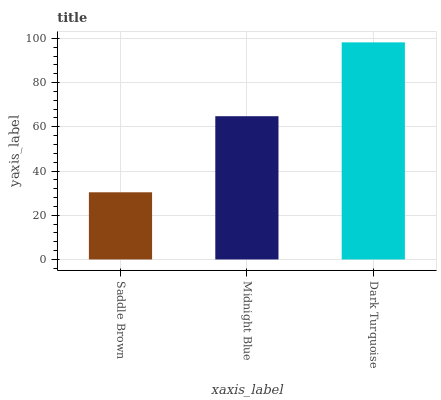Is Saddle Brown the minimum?
Answer yes or no. Yes. Is Dark Turquoise the maximum?
Answer yes or no. Yes. Is Midnight Blue the minimum?
Answer yes or no. No. Is Midnight Blue the maximum?
Answer yes or no. No. Is Midnight Blue greater than Saddle Brown?
Answer yes or no. Yes. Is Saddle Brown less than Midnight Blue?
Answer yes or no. Yes. Is Saddle Brown greater than Midnight Blue?
Answer yes or no. No. Is Midnight Blue less than Saddle Brown?
Answer yes or no. No. Is Midnight Blue the high median?
Answer yes or no. Yes. Is Midnight Blue the low median?
Answer yes or no. Yes. Is Dark Turquoise the high median?
Answer yes or no. No. Is Saddle Brown the low median?
Answer yes or no. No. 